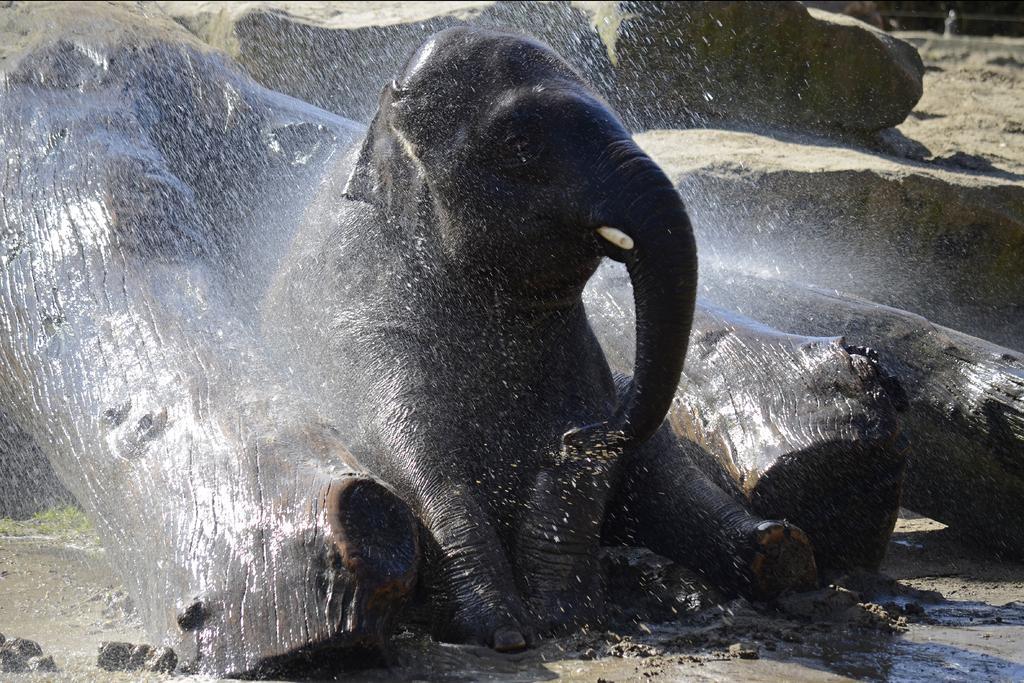In one or two sentences, can you explain what this image depicts? There is an elephant. Also there are wooden logs. And there is shower of water. In the back there are rocks. 